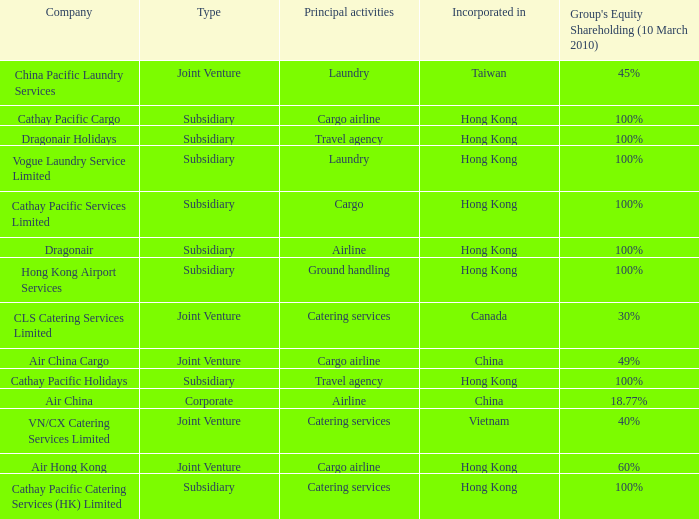What is the name of the company that has a Group's equity shareholding percentage, as of March 10th, 2010, of 100%, as well as a Principal activity of Airline? Dragonair. 